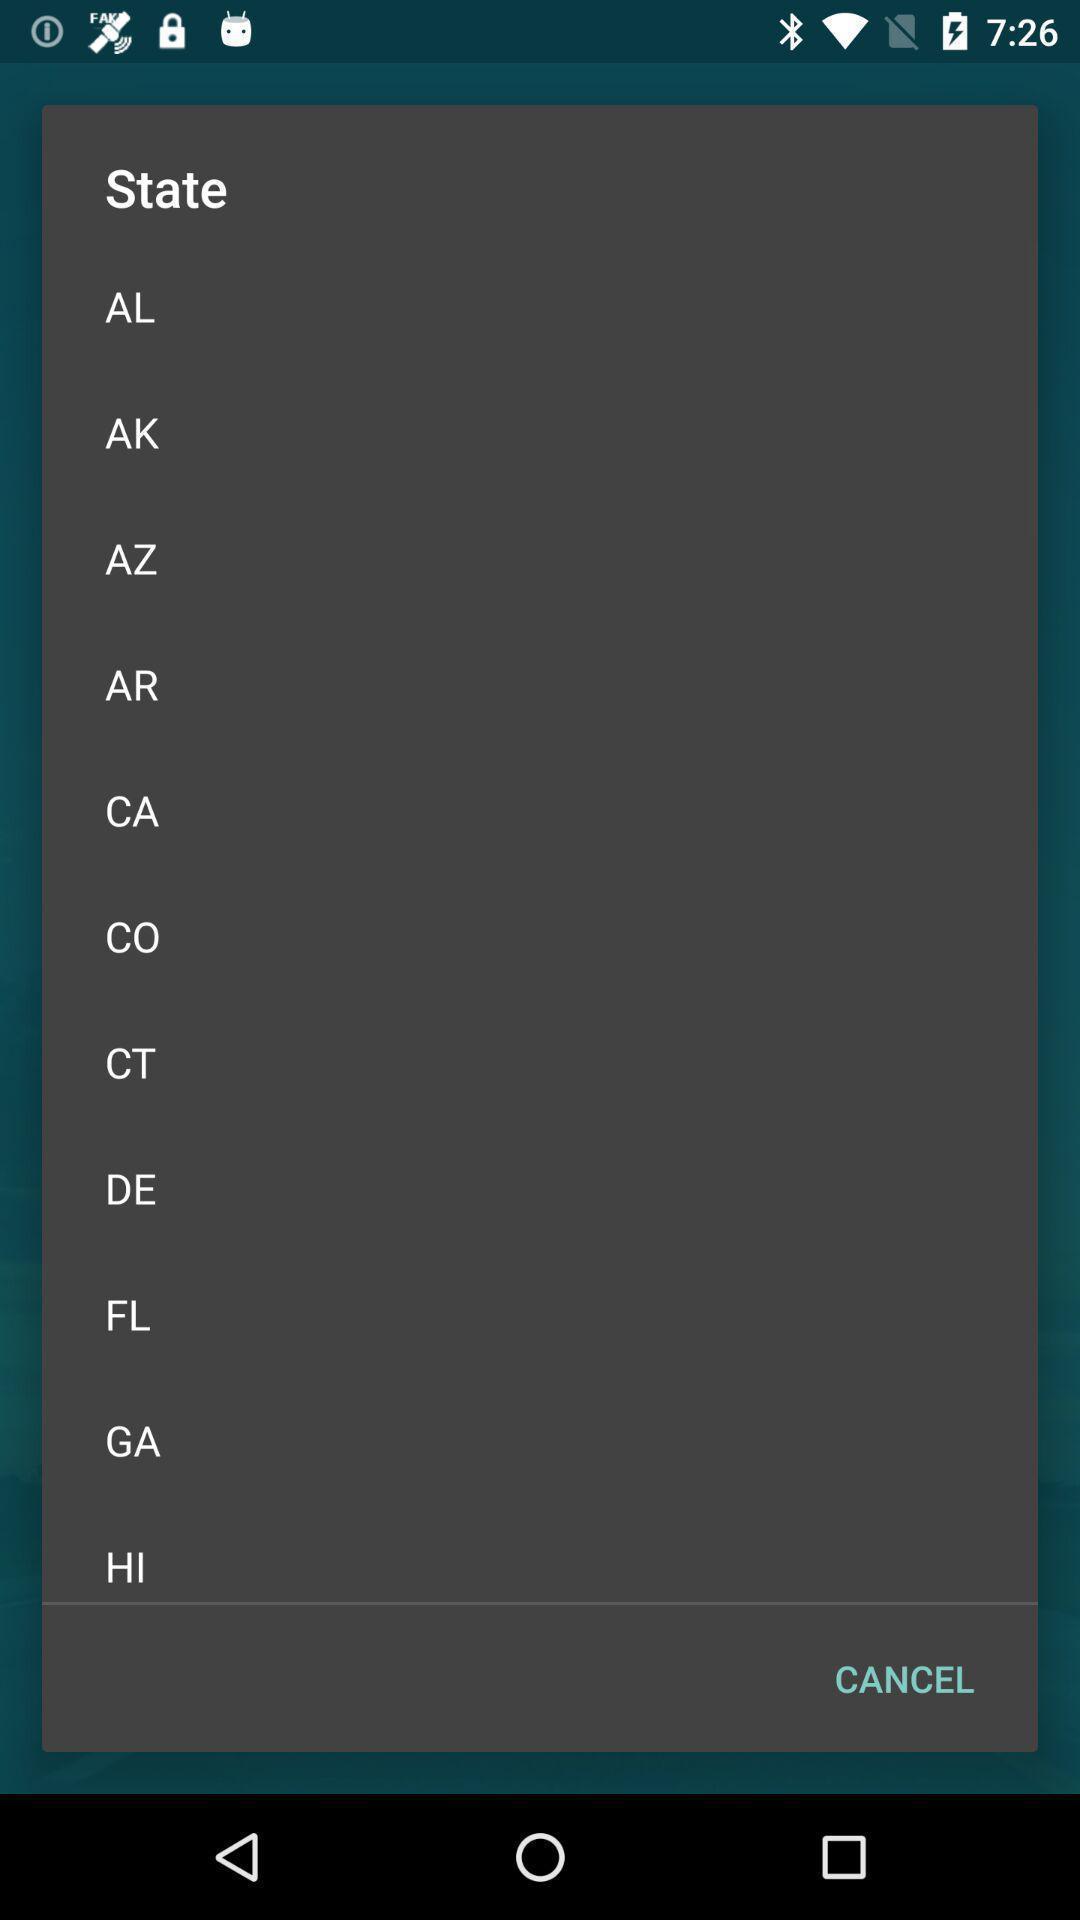Give me a summary of this screen capture. Popup displaying information about travel and vehicle health management application. 